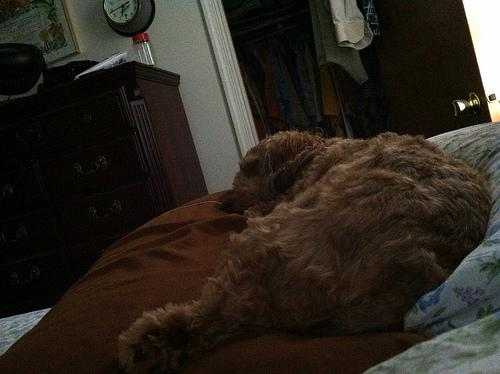Question: who can seen with the dog?
Choices:
A. The blind man.
B. No one.
C. The blind woman.
D. The blind child.
Answer with the letter. Answer: B Question: where is the dog laying?
Choices:
A. On the couch.
B. On the dog bed.
C. In the bed.
D. On the rug.
Answer with the letter. Answer: C Question: what color are the walls?
Choices:
A. White.
B. Blue.
C. Pink.
D. Tan.
Answer with the letter. Answer: A Question: when was the picture taken?
Choices:
A. Yesterday.
B. After the dog was done playing.
C. Noon.
D. When the dog was sleeping.
Answer with the letter. Answer: D Question: how many dogs are in the picture?
Choices:
A. One.
B. Two.
C. Four.
D. Seven.
Answer with the letter. Answer: A 